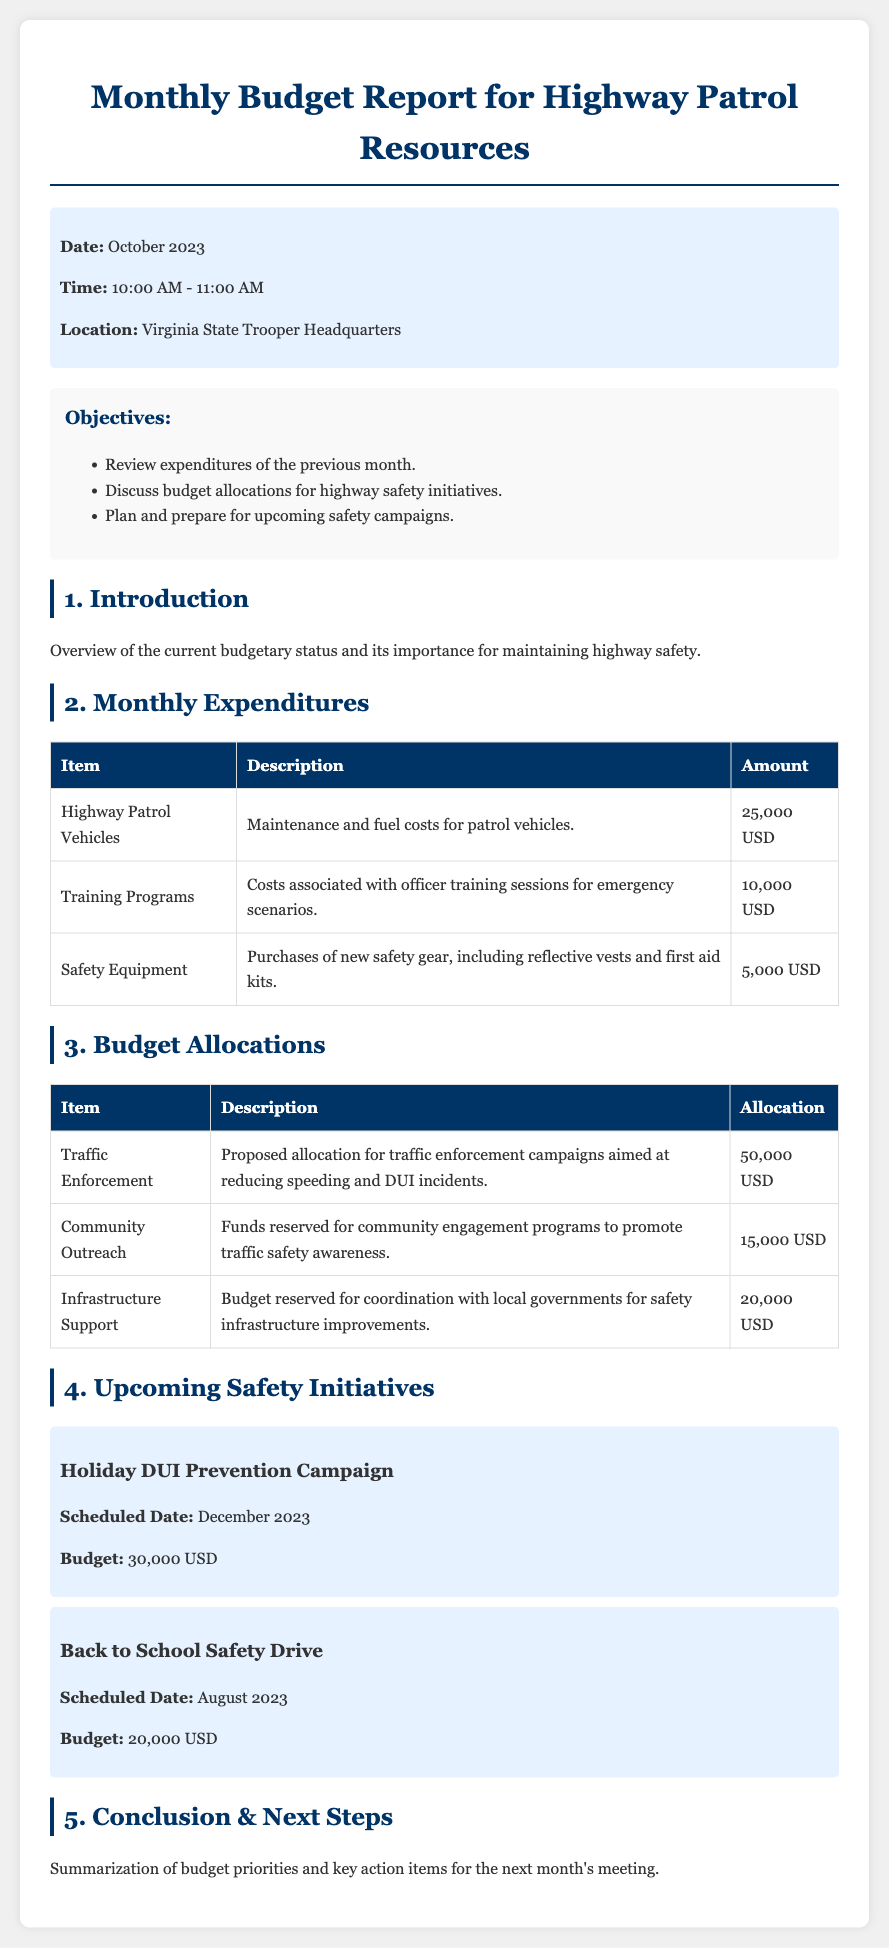What is the scheduled date for the Holiday DUI Prevention Campaign? The document states that the scheduled date for the Holiday DUI Prevention Campaign is December 2023.
Answer: December 2023 How much was spent on officer training programs last month? According to the table of monthly expenditures, the cost associated with officer training programs was $10,000.
Answer: 10,000 USD What is the total allocation for Traffic Enforcement campaigns? The document specifies that the proposed allocation for Traffic Enforcement campaigns is $50,000.
Answer: 50,000 USD How much budget is reserved for Community Outreach? The budget allocation table indicates that the funds reserved for Community Outreach programs total $15,000.
Answer: 15,000 USD What are the main objectives of this monthly budget report? The document lists three main objectives: review expenditures, discuss budget allocations, and plan for upcoming safety campaigns.
Answer: Review expenditures, discuss budget allocations, plan for upcoming safety campaigns What is the total amount spent on Safety Equipment? The document shows that the total spent on Safety Equipment last month was $5,000.
Answer: 5,000 USD What are the key action items mentioned in the conclusion? The conclusion highlights budget priorities and key action items for the next month's meeting, although specific items are not listed.
Answer: Key action items What is the total budget for the Back to School Safety Drive? According to the upcoming safety initiatives section, the budget for the Back to School Safety Drive is $20,000.
Answer: 20,000 USD 